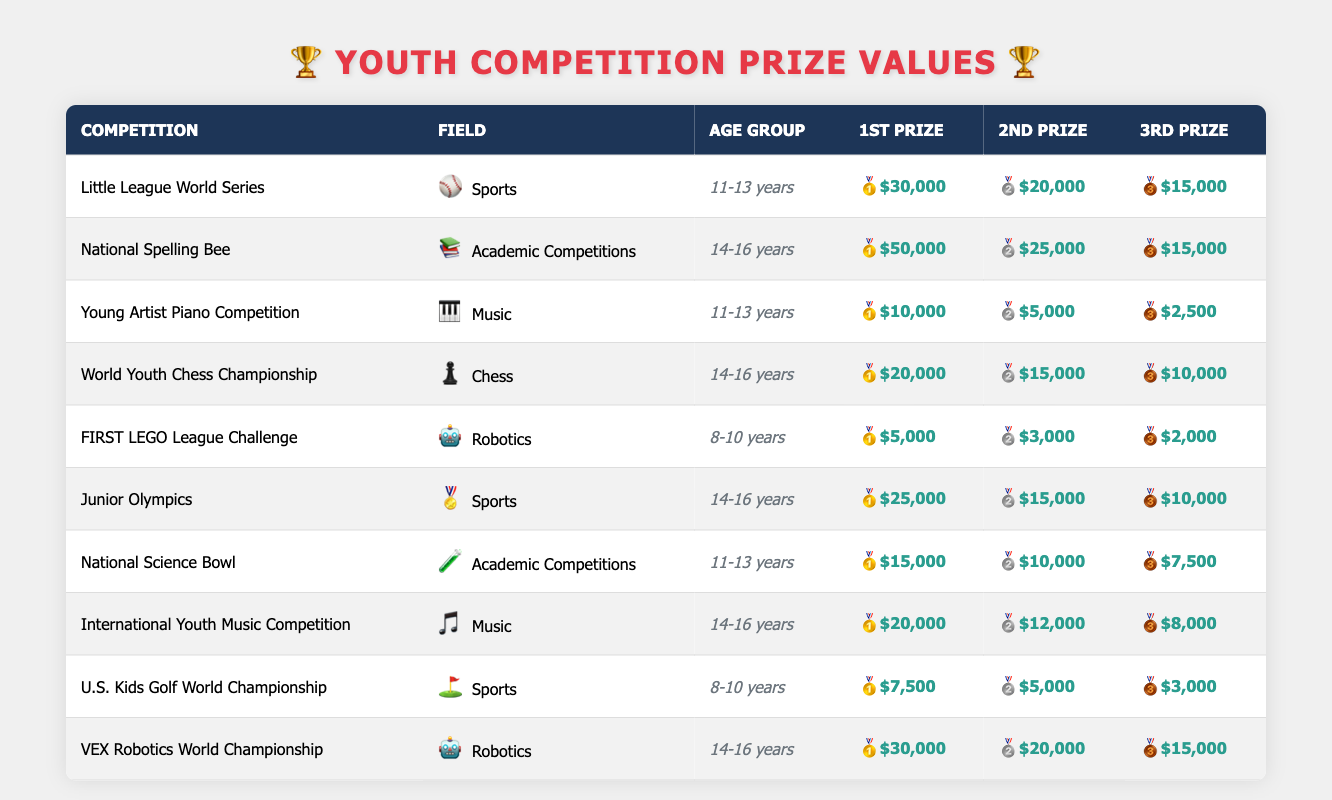What is the first prize value for the National Spelling Bee? The National Spelling Bee competition falls under the category of Academic Competitions for the age group of 14-16 years. According to the table, the first prize value for this competition is $50,000.
Answer: $50,000 Which age group has the highest first prize in Sports? The table includes two Sports competitions: the Little League World Series for 11-13 years with a first prize of $30,000, and the Junior Olympics for 14-16 years with a first prize of $25,000. The highest figure is in the Little League World Series, making the 11-13 age group the one with the highest first prize.
Answer: 11-13 years What is the total value of the 1st, 2nd, and 3rd prizes for the VEX Robotics World Championship? The first prize is $30,000, the second prize is $20,000, and the third prize is $15,000. To find the total, we add these values: $30,000 + $20,000 + $15,000 = $65,000.
Answer: $65,000 Does the FIRST LEGO League Challenge have a higher second prize than the Young Artist Piano Competition? The FIRST LEGO League Challenge offers a second prize of $3,000, while the Young Artist Piano Competition offers a second prize of $5,000. Since $3,000 is less than $5,000, the statement is false.
Answer: No What is the difference between the first prize for the World Youth Chess Championship and the first prize for the International Youth Music Competition? The World Youth Chess Championship has a first prize value of $20,000, while the International Youth Music Competition has a first prize value of $20,000 as well. Therefore, the difference is $20,000 - $20,000 = $0, meaning there is no difference.
Answer: $0 Which field offers the highest total prize value among its competitions for the age group 14-16 years? There are two competitions in the age group 14-16 years: the National Spelling Bee and the Junior Olympics in Academic Competitions and Sports, respectively. Adding their first, second, and third prizes: National Spelling Bee ($50,000 + $25,000 + $15,000 = $90,000) and Junior Olympics ($25,000 + $15,000 + $10,000 = $50,000). Academic Competitions has the highest total at $90,000.
Answer: Academic Competitions What is the average value of the 3rd prizes across all Robotics competitions? The only Robotics competitions are the FIRST LEGO League Challenge and the VEX Robotics World Championship, which have 3rd prize values of $2,000 and $15,000 respectively. To find the average, we calculate: ($2,000 + $15,000) / 2 = $8,500.
Answer: $8,500 Is the second prize for the World Youth Chess Championship greater than the first prize for the U.S. Kids Golf World Championship? The second prize for the World Youth Chess Championship is $15,000 and the first prize for the U.S. Kids Golf World Championship is $7,500. Since $15,000 is greater than $7,500, the statement is true.
Answer: Yes 